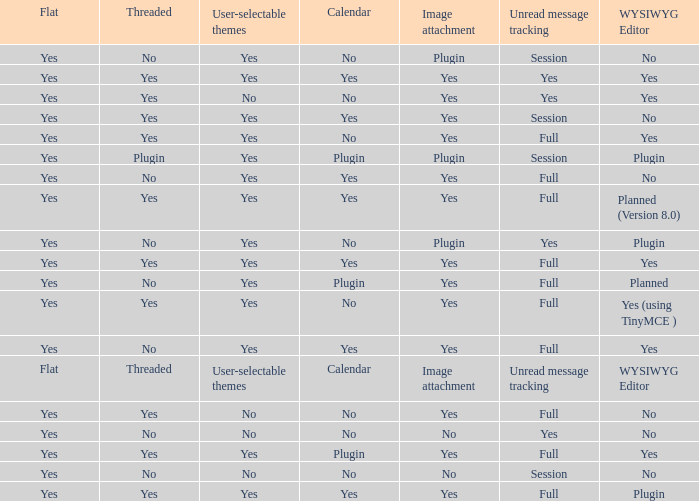Which Image attachment has a Threaded of yes, and a Calendar of yes? Yes, Yes, Yes, Yes, Yes. 